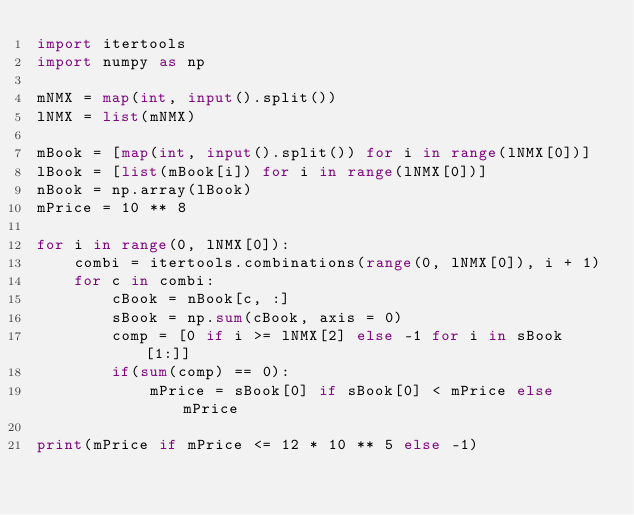<code> <loc_0><loc_0><loc_500><loc_500><_Python_>import itertools
import numpy as np

mNMX = map(int, input().split())
lNMX = list(mNMX)

mBook = [map(int, input().split()) for i in range(lNMX[0])]
lBook = [list(mBook[i]) for i in range(lNMX[0])]
nBook = np.array(lBook)
mPrice = 10 ** 8

for i in range(0, lNMX[0]):
    combi = itertools.combinations(range(0, lNMX[0]), i + 1)
    for c in combi:
        cBook = nBook[c, :]
        sBook = np.sum(cBook, axis = 0)
        comp = [0 if i >= lNMX[2] else -1 for i in sBook[1:]]
        if(sum(comp) == 0):
            mPrice = sBook[0] if sBook[0] < mPrice else mPrice
    
print(mPrice if mPrice <= 12 * 10 ** 5 else -1)</code> 